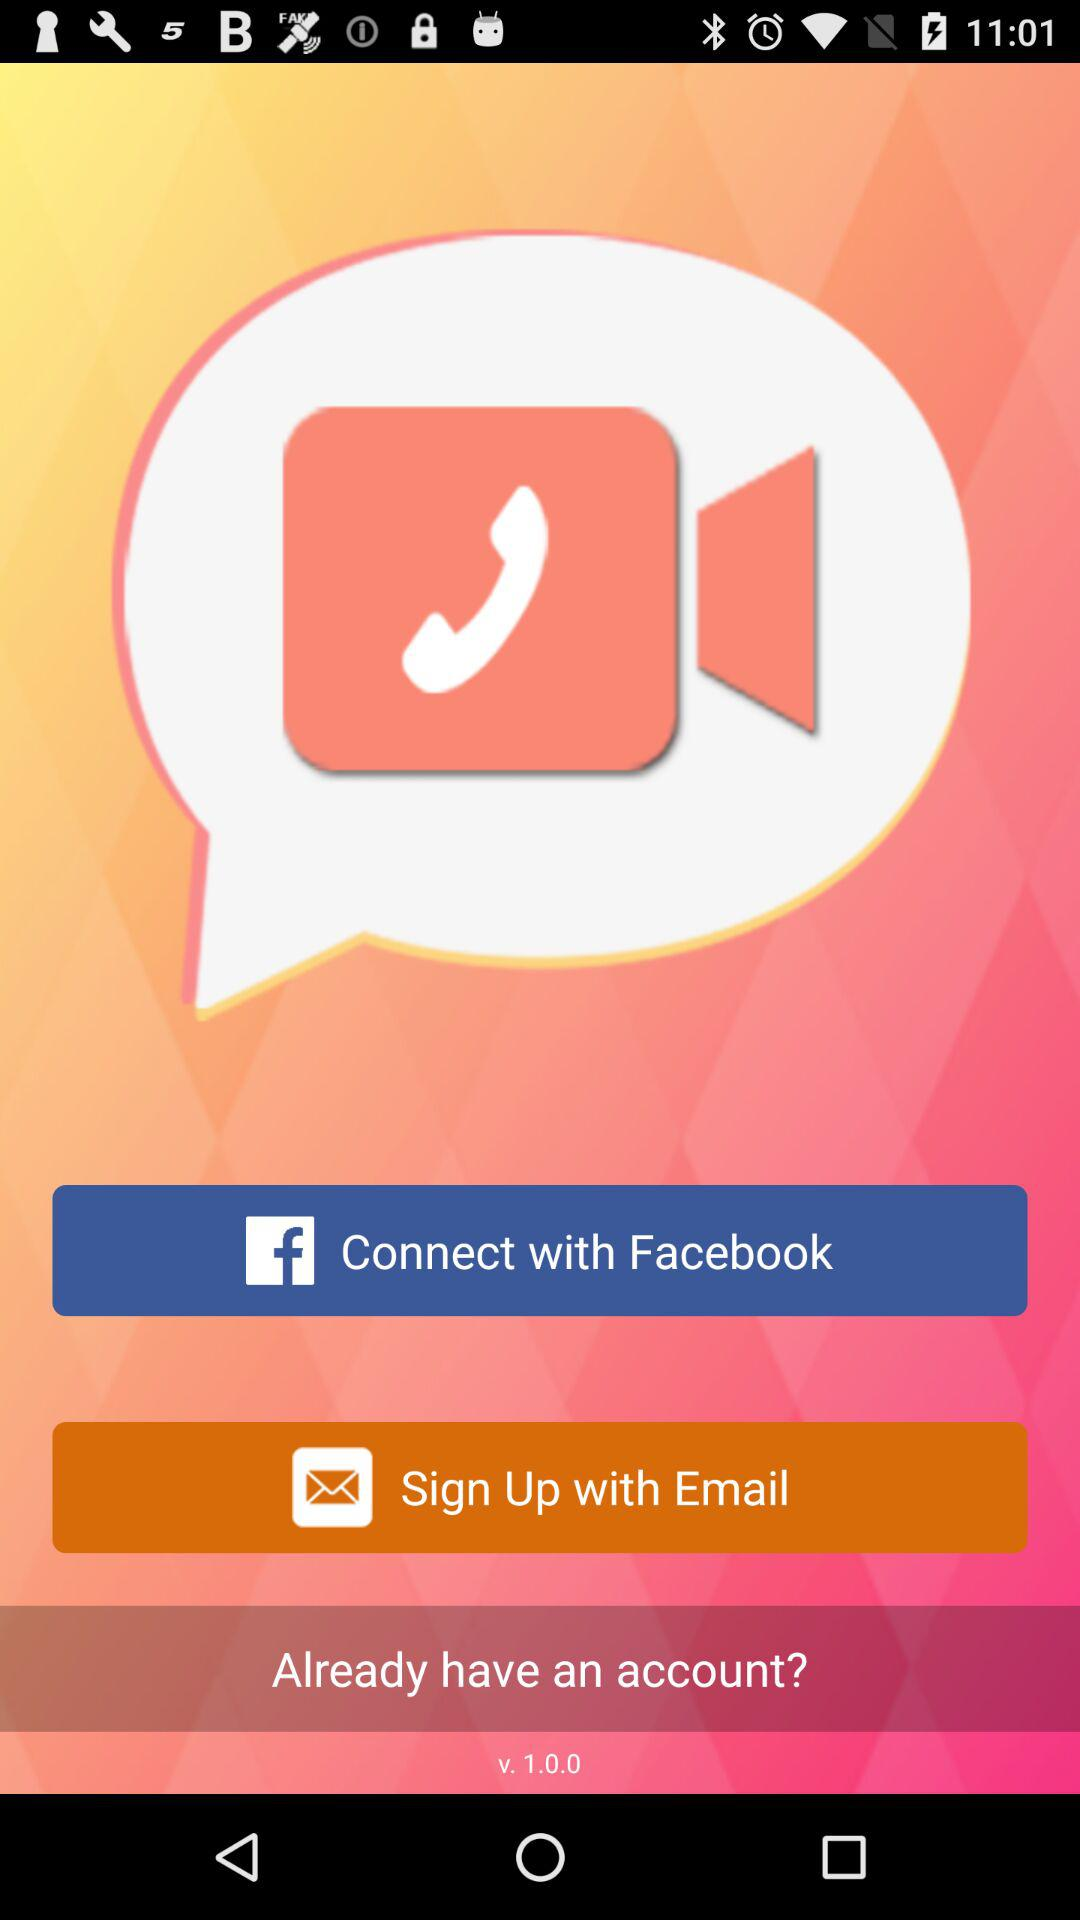What app can we sign in to? You can sign in to "Facebook", and "Email". 